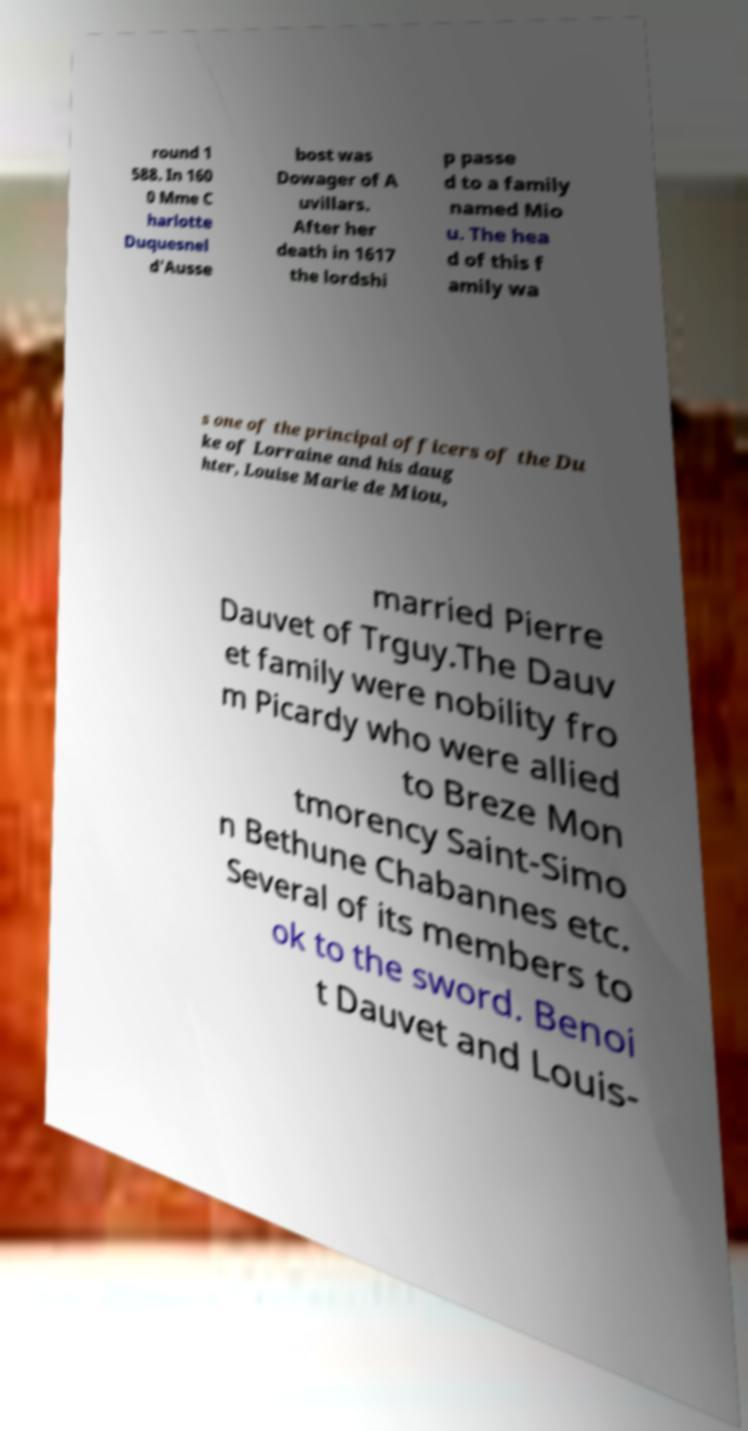For documentation purposes, I need the text within this image transcribed. Could you provide that? round 1 588. In 160 0 Mme C harlotte Duquesnel d'Ausse bost was Dowager of A uvillars. After her death in 1617 the lordshi p passe d to a family named Mio u. The hea d of this f amily wa s one of the principal officers of the Du ke of Lorraine and his daug hter, Louise Marie de Miou, married Pierre Dauvet of Trguy.The Dauv et family were nobility fro m Picardy who were allied to Breze Mon tmorency Saint-Simo n Bethune Chabannes etc. Several of its members to ok to the sword. Benoi t Dauvet and Louis- 